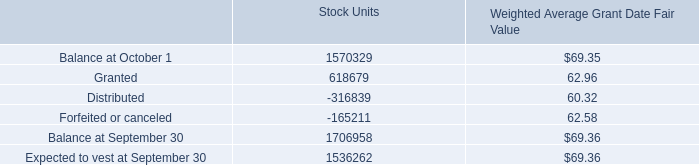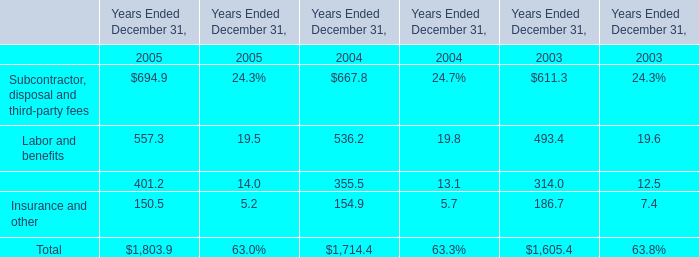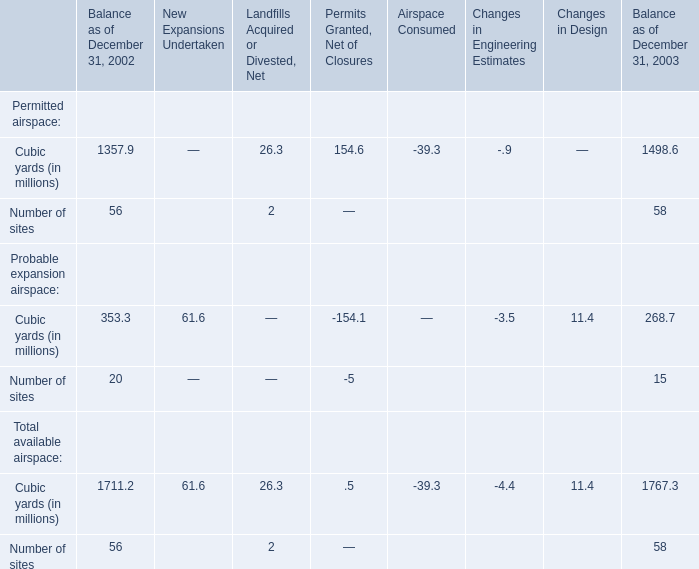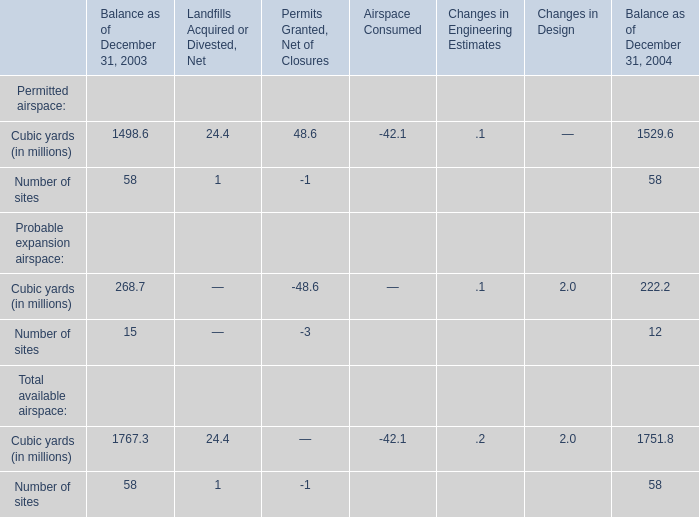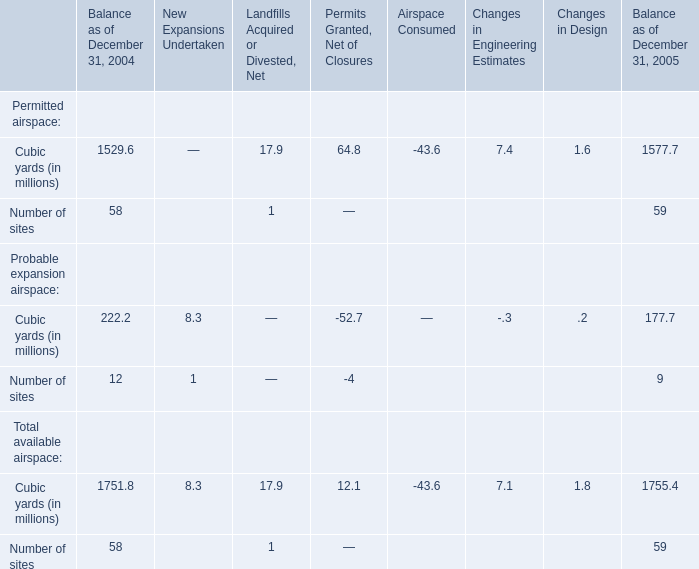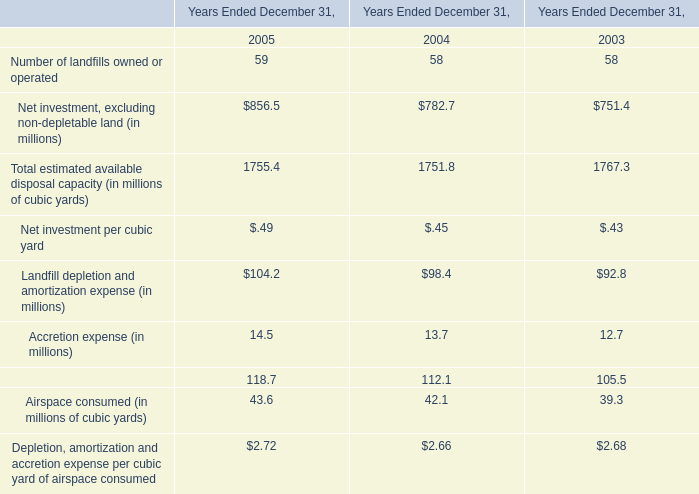what is the total fair value of performance-based restricted stock units vested during 2009 , 2008 and 2007? 
Computations: ((33712 + 49387) + 9181)
Answer: 92280.0. 